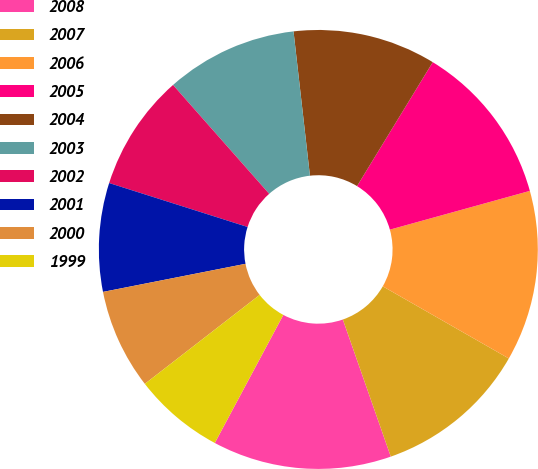Convert chart to OTSL. <chart><loc_0><loc_0><loc_500><loc_500><pie_chart><fcel>2008<fcel>2007<fcel>2006<fcel>2005<fcel>2004<fcel>2003<fcel>2002<fcel>2001<fcel>2000<fcel>1999<nl><fcel>13.17%<fcel>11.37%<fcel>12.57%<fcel>11.97%<fcel>10.53%<fcel>9.71%<fcel>8.59%<fcel>7.99%<fcel>7.39%<fcel>6.69%<nl></chart> 